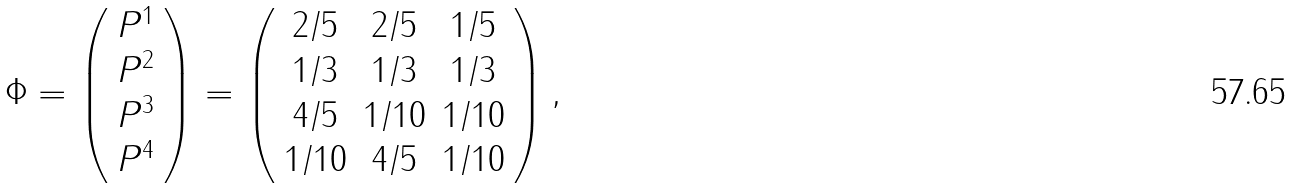Convert formula to latex. <formula><loc_0><loc_0><loc_500><loc_500>\Phi = \left ( \begin{array} { c } P ^ { 1 } \\ P ^ { 2 } \\ P ^ { 3 } \\ P ^ { 4 } \end{array} \right ) = \left ( \begin{array} { c c c } 2 / 5 & 2 / 5 & 1 / 5 \\ 1 / 3 & 1 / 3 & 1 / 3 \\ 4 / 5 & 1 / 1 0 & 1 / 1 0 \\ 1 / 1 0 & 4 / 5 & 1 / 1 0 \end{array} \right ) ,</formula> 